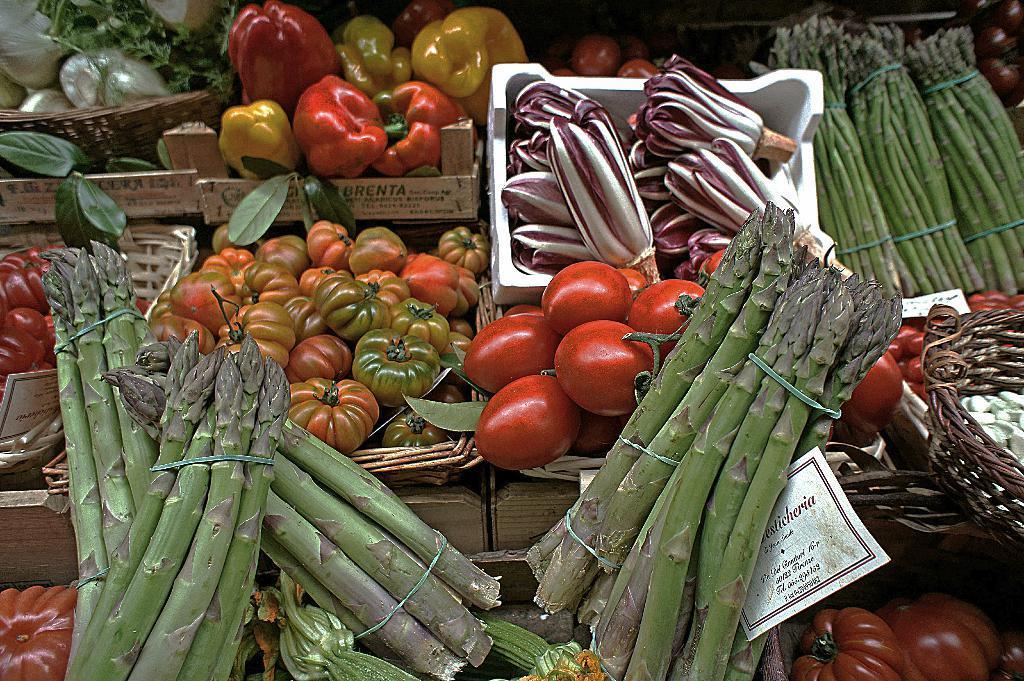In one or two sentences, can you explain what this image depicts? In this image we can see some vegetables like tomatoes, capsicum and radicchio which are placed in the baskets. We can also see some crops which are tied with a thread. On the right side we can see a paper with some text on it. 